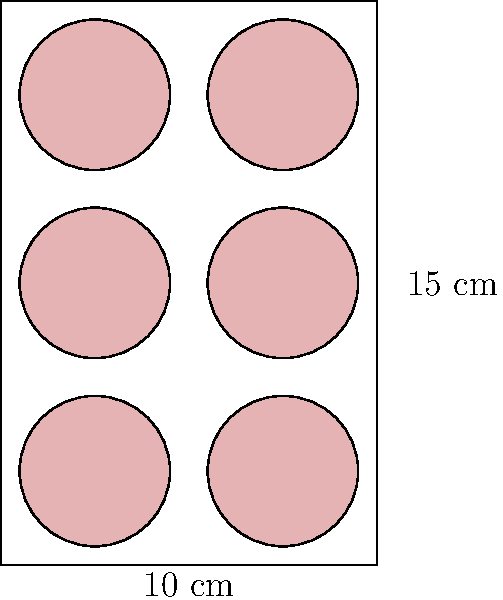You're preparing a Gilmore Girls-themed watch party and want to bake circular pastries inspired by Sookie's famous desserts. Given a rectangular baking tray measuring 10 cm by 15 cm, and circular pastries with a diameter of 4 cm, what is the maximum number of pastries you can fit on the tray without overlapping? Let's approach this step-by-step:

1. Tray dimensions:
   - Width (w) = 10 cm
   - Height (h) = 15 cm

2. Pastry dimensions:
   - Diameter (d) = 4 cm
   - Radius (r) = 2 cm

3. Calculate how many pastries can fit along the width:
   - Number along width = floor(w / d) = floor(10 / 4) = 2

4. Calculate how many pastries can fit along the height:
   - Number along height = floor(h / d) = floor(15 / 4) = 3

5. Calculate the total number of pastries:
   - Total = (Number along width) × (Number along height)
   - Total = 2 × 3 = 6

6. Verify that this arrangement leaves no space for an additional pastry:
   - Remaining width: 10 cm - (2 × 4 cm) = 2 cm < 4 cm
   - Remaining height: 15 cm - (3 × 4 cm) = 3 cm < 4 cm

Therefore, the maximum number of 4 cm diameter circular pastries that can fit on the 10 cm × 15 cm tray is 6.
Answer: 6 pastries 